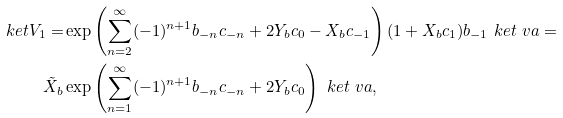<formula> <loc_0><loc_0><loc_500><loc_500>\ k e t { V _ { 1 } } = & \exp \left ( \sum _ { n = 2 } ^ { \infty } ( - 1 ) ^ { n + 1 } b _ { - n } c _ { - n } + 2 Y _ { b } c _ { 0 } - X _ { b } c _ { - 1 } \right ) ( 1 + X _ { b } c _ { 1 } ) b _ { - 1 } \ k e t { \ v a } = \\ \tilde { X } _ { b } & \exp \left ( \sum _ { n = 1 } ^ { \infty } ( - 1 ) ^ { n + 1 } b _ { - n } c _ { - n } + 2 Y _ { b } c _ { 0 } \right ) \ k e t { \ v a } ,</formula> 